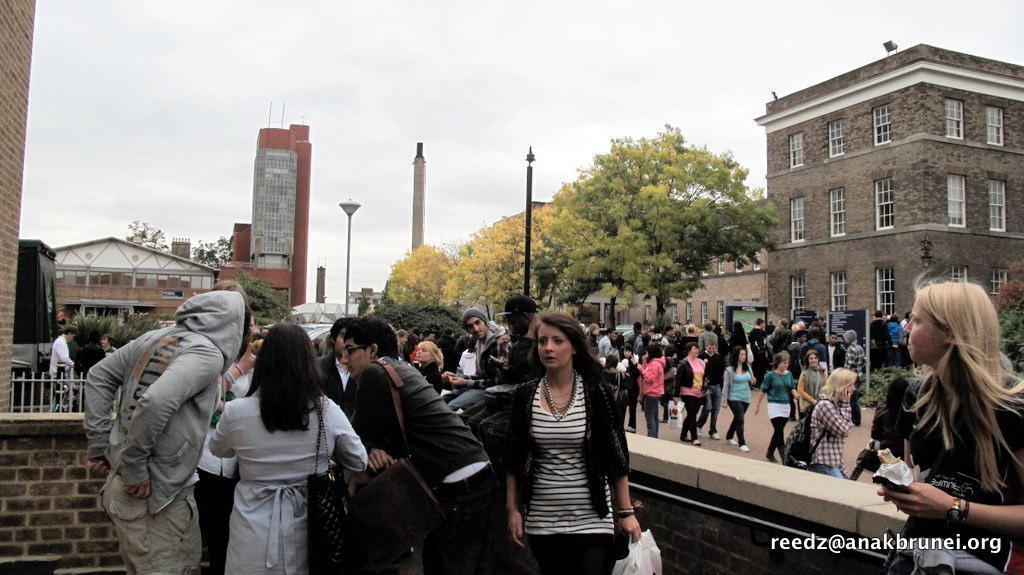Describe this image in one or two sentences. This image consists of many people standing and walking on the road. To the left, there are buildings. In the background, there are trees along with poles and buildings. 